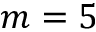<formula> <loc_0><loc_0><loc_500><loc_500>m = 5</formula> 